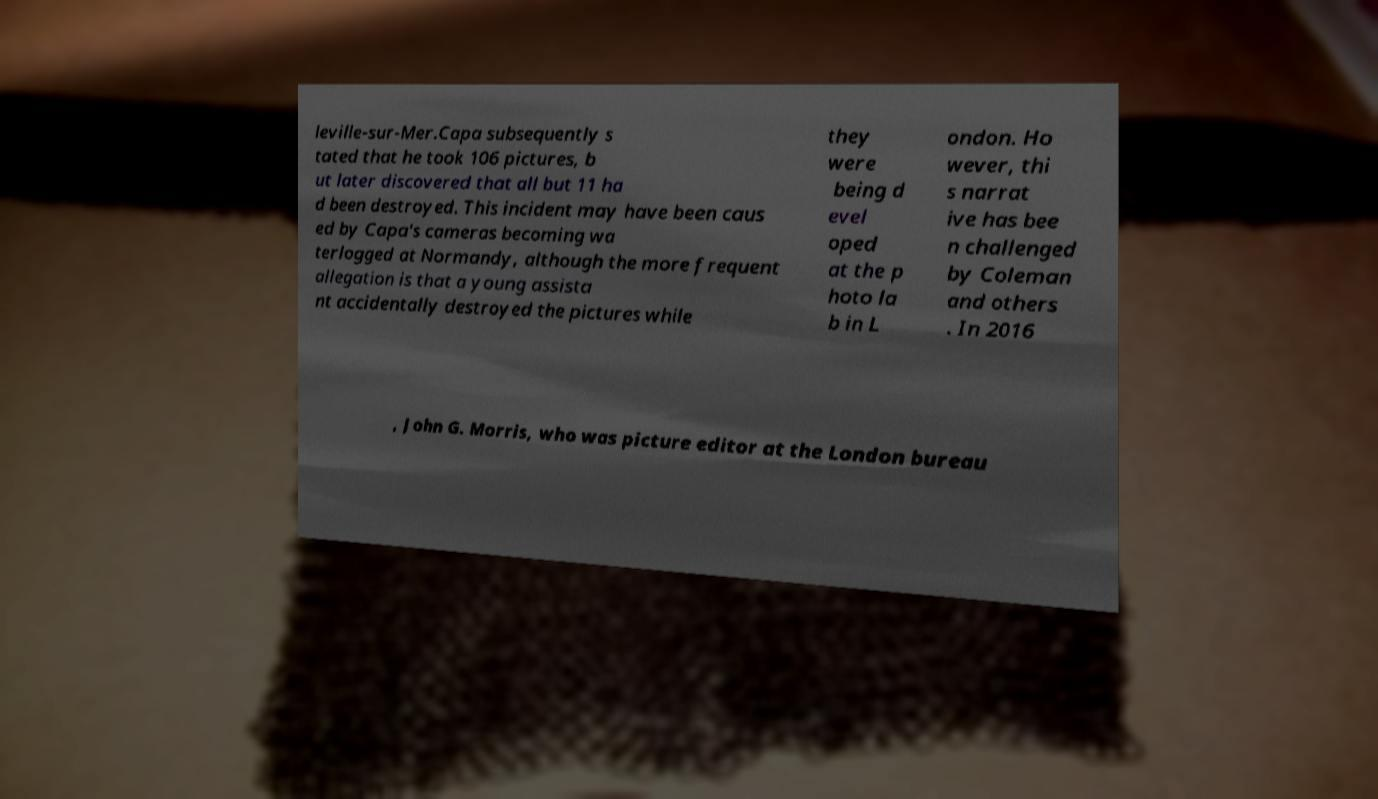Can you accurately transcribe the text from the provided image for me? leville-sur-Mer.Capa subsequently s tated that he took 106 pictures, b ut later discovered that all but 11 ha d been destroyed. This incident may have been caus ed by Capa's cameras becoming wa terlogged at Normandy, although the more frequent allegation is that a young assista nt accidentally destroyed the pictures while they were being d evel oped at the p hoto la b in L ondon. Ho wever, thi s narrat ive has bee n challenged by Coleman and others . In 2016 , John G. Morris, who was picture editor at the London bureau 